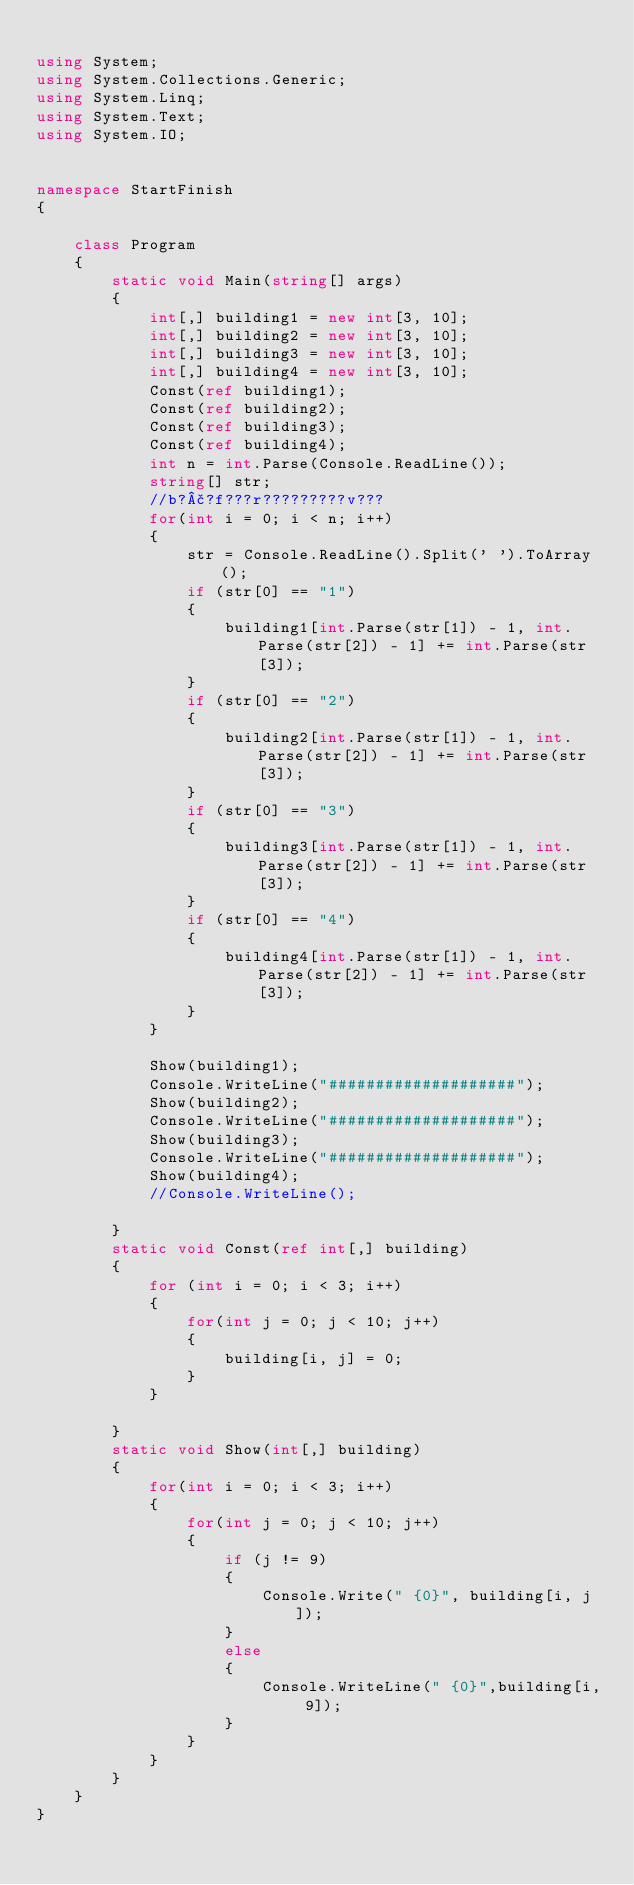Convert code to text. <code><loc_0><loc_0><loc_500><loc_500><_C#_>
using System;
using System.Collections.Generic;
using System.Linq;
using System.Text;
using System.IO;


namespace StartFinish
{
 
    class Program
    {
        static void Main(string[] args)
        {
            int[,] building1 = new int[3, 10];
            int[,] building2 = new int[3, 10];
            int[,] building3 = new int[3, 10];
            int[,] building4 = new int[3, 10];
            Const(ref building1);
            Const(ref building2);
            Const(ref building3);
            Const(ref building4);
            int n = int.Parse(Console.ReadLine());
            string[] str;
            //b?£?f???r?????????v???
            for(int i = 0; i < n; i++)
            {
                str = Console.ReadLine().Split(' ').ToArray();
                if (str[0] == "1")
                {
                    building1[int.Parse(str[1]) - 1, int.Parse(str[2]) - 1] += int.Parse(str[3]);
                }
                if (str[0] == "2")
                {
                    building2[int.Parse(str[1]) - 1, int.Parse(str[2]) - 1] += int.Parse(str[3]);
                }
                if (str[0] == "3")
                {
                    building3[int.Parse(str[1]) - 1, int.Parse(str[2]) - 1] += int.Parse(str[3]);
                }
                if (str[0] == "4")
                {
                    building4[int.Parse(str[1]) - 1, int.Parse(str[2]) - 1] += int.Parse(str[3]);
                }
            }

            Show(building1);
            Console.WriteLine("####################");
            Show(building2);
            Console.WriteLine("####################");
            Show(building3);
            Console.WriteLine("####################");
            Show(building4);
            //Console.WriteLine();

        }
        static void Const(ref int[,] building)
        {
            for (int i = 0; i < 3; i++)
            {
                for(int j = 0; j < 10; j++)
                {
                    building[i, j] = 0;
                }
            }

        }
        static void Show(int[,] building)
        {
            for(int i = 0; i < 3; i++)
            {
                for(int j = 0; j < 10; j++)
                {
                    if (j != 9)
                    {
                        Console.Write(" {0}", building[i, j]);
                    }
                    else
                    {
                        Console.WriteLine(" {0}",building[i, 9]);
                    }
                }
            }
        }
    }
}</code> 